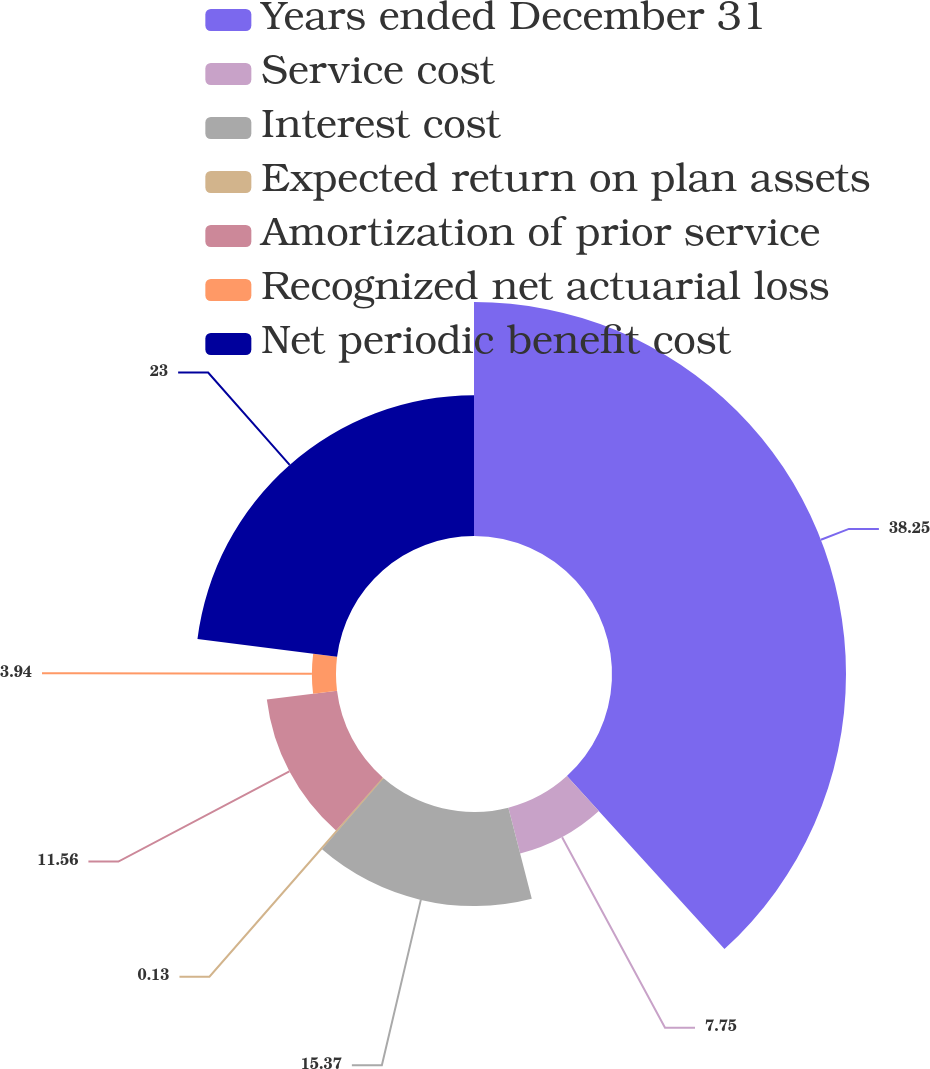Convert chart to OTSL. <chart><loc_0><loc_0><loc_500><loc_500><pie_chart><fcel>Years ended December 31<fcel>Service cost<fcel>Interest cost<fcel>Expected return on plan assets<fcel>Amortization of prior service<fcel>Recognized net actuarial loss<fcel>Net periodic benefit cost<nl><fcel>38.24%<fcel>7.75%<fcel>15.37%<fcel>0.13%<fcel>11.56%<fcel>3.94%<fcel>23.0%<nl></chart> 